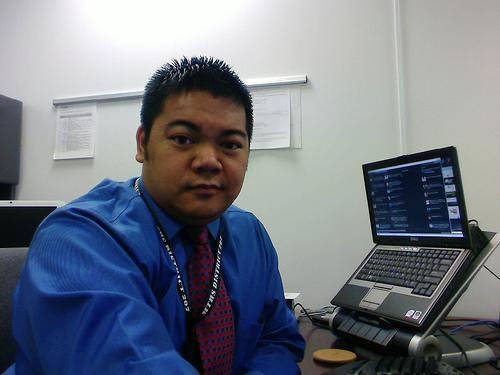How many females in the photo?
Give a very brief answer. 0. 